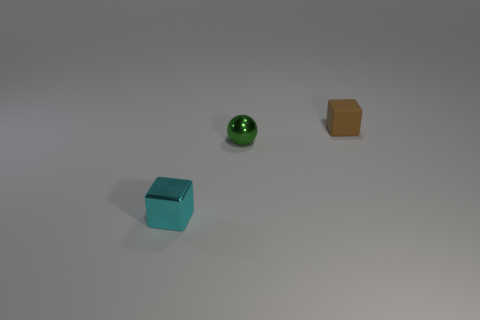Is there anything else that is the same color as the metal block? no 